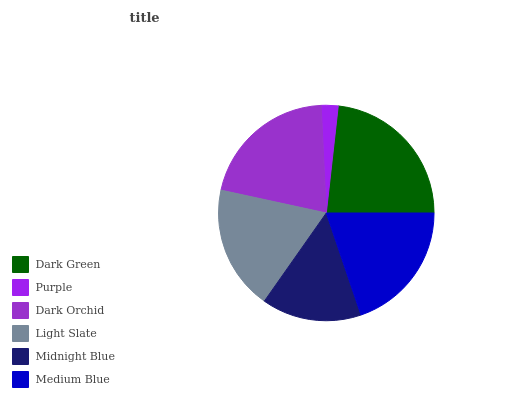Is Purple the minimum?
Answer yes or no. Yes. Is Dark Green the maximum?
Answer yes or no. Yes. Is Dark Orchid the minimum?
Answer yes or no. No. Is Dark Orchid the maximum?
Answer yes or no. No. Is Dark Orchid greater than Purple?
Answer yes or no. Yes. Is Purple less than Dark Orchid?
Answer yes or no. Yes. Is Purple greater than Dark Orchid?
Answer yes or no. No. Is Dark Orchid less than Purple?
Answer yes or no. No. Is Medium Blue the high median?
Answer yes or no. Yes. Is Light Slate the low median?
Answer yes or no. Yes. Is Purple the high median?
Answer yes or no. No. Is Purple the low median?
Answer yes or no. No. 